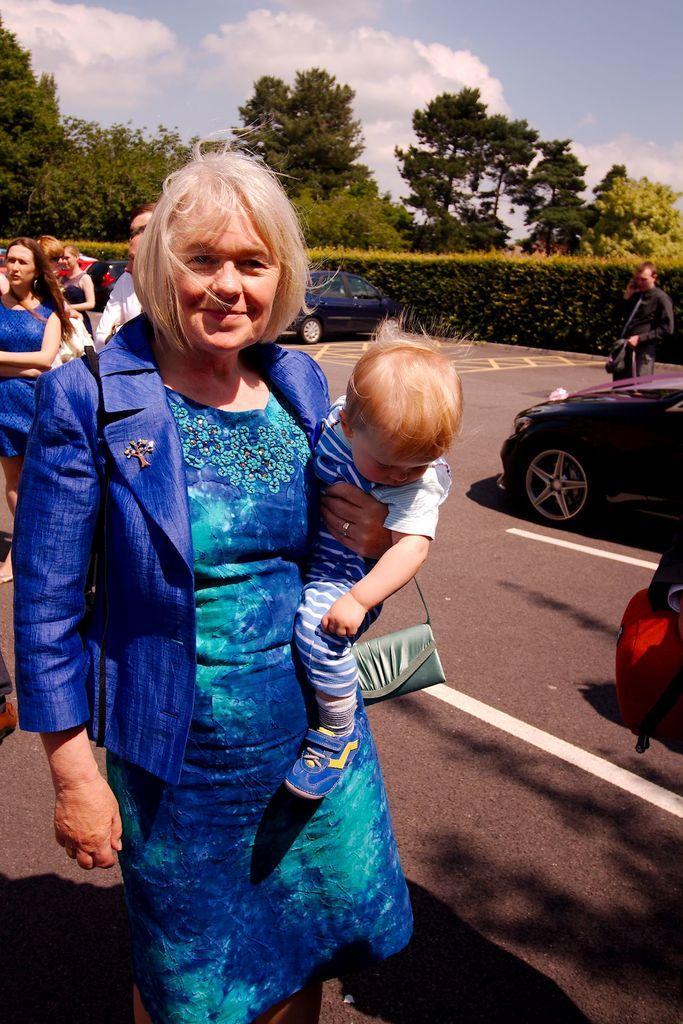In one or two sentences, can you explain what this image depicts? In this image we can see a woman is holding a baby in her hand. She is wearing a blue color dress with blue coat. In the background, we can see people, cars, road, plants and tree. At the top of the image, we can see the sky with clouds. 